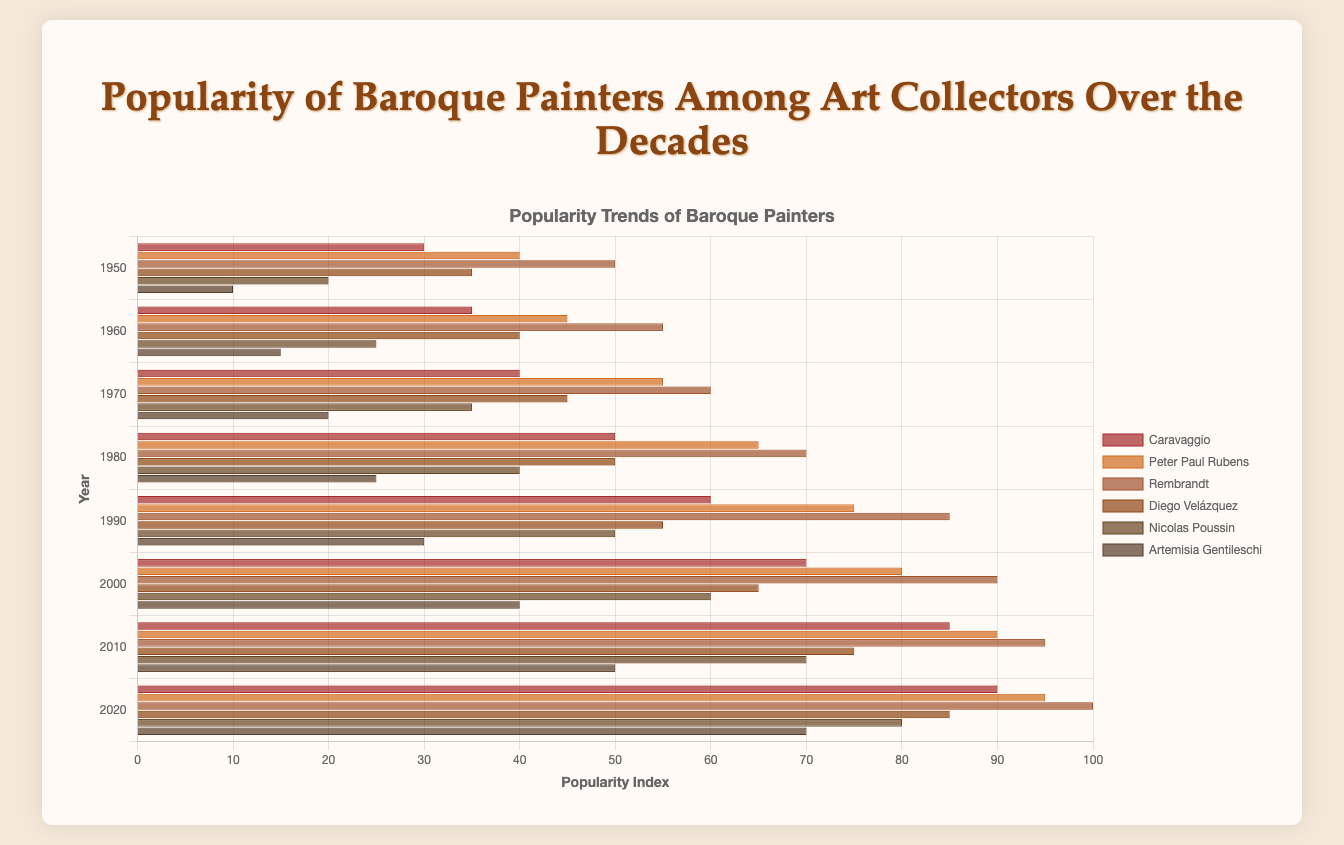Which painter had the highest popularity index in 2020? The chart shows the popularity indices for all painters across different years. The highest popularity index in 2020 is 100, which belongs to Rembrandt.
Answer: Rembrandt Which painter showed the greatest increase in popularity from 1950 to 2020? To determine this, calculate the difference in popularity indices between 1950 and 2020 for each painter. The differences are: Caravaggio (90-30=60), Peter Paul Rubens (95-40=55), Rembrandt (100-50=50), Diego Velázquez (85-35=50), Nicolas Poussin (80-20=60), Artemisia Gentileschi (70-10=60). Caravaggio, Nicolas Poussin, and Artemisia Gentileschi each show an increase of 60 points.
Answer: Caravaggio, Nicolas Poussin, Artemisia Gentileschi Which painter had the lowest popularity index in 1970? The chart shows the popularity indices for 1970. The lowest index is 20, which belongs to Artemisia Gentileschi.
Answer: Artemisia Gentileschi How many painters had a popularity index of 85 or higher by 2020? Check the chart for the indices in 2020. The painters with indices of 85 or higher in 2020 are Caravaggio (90), Peter Paul Rubens (95), Rembrandt (100), Diego Velázquez (85). There are 4 painters in total.
Answer: 4 Which two painters had the closest popularity indices in 1980, and what were their indices? Compare the indices for 1980. Caravaggio and Diego Velázquez both have an index of 50, making their indices the closest with a difference of 0.
Answer: Caravaggio and Diego Velázquez, 50 What is the average popularity index of Peter Paul Rubens from 1950 to 2020? Add the popularity indices for Peter Paul Rubens from each year (40 + 45 + 55 + 65 + 75 + 80 + 90 + 95) and divide by the number of years (8). The total sum is 545, so the average is 545/8 = 68.13
Answer: 68.13 Which painter's popularity increased the most between 1990 and 2000? Calculate the difference between 2000 and 1990 indices for each painter. The differences are: Caravaggio (70-60=10), Peter Paul Rubens (80-75=5), Rembrandt (90-85=5), Diego Velázquez (65-55=10), Nicolas Poussin (60-50=10), Artemisia Gentileschi (40-30=10). There are multiple painters (Caravaggio, Diego Velázquez, Nicolas Poussin, Artemisia Gentileschi) with the highest increase of 10.
Answer: Caravaggio, Diego Velázquez, Nicolas Poussin, Artemisia Gentileschi Which painter had consistent year-by-year increases in popularity from 1950 to 2020? Review the chart for consistent, non-decreasing indices across the years. All painters show consistent increases in their popularity indices over the decades.
Answer: All painters Which painter had the steepest increase in popularity index in a single decade, and in which decade? Review the increases per decade for each painter: Caravaggio (1980-1990, 10), Peter Paul Rubens (1970-1980, 10), Rembrandt (1980-1990, 15), Diego Velázquez (2000-2010, 10), Nicolas Poussin (1950-1960, 5), Artemisia Gentileschi (2010-2020, 20). Artemisia Gentileschi had the steepest increase of 20 points between 2010 and 2020.
Answer: Artemisia Gentileschi, 2010-2020 